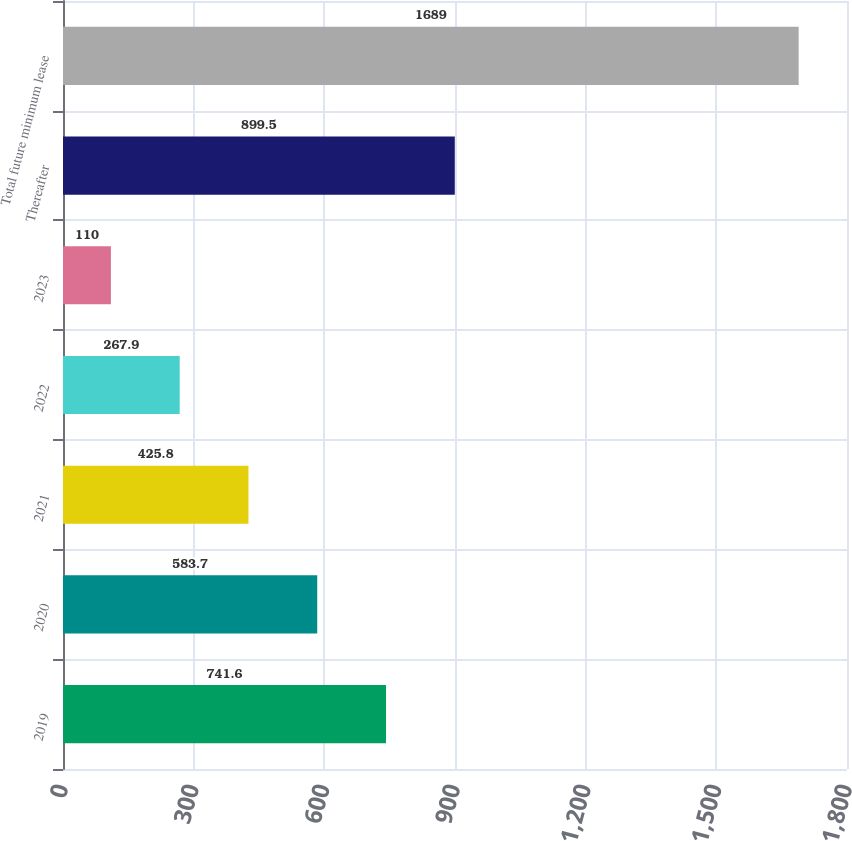<chart> <loc_0><loc_0><loc_500><loc_500><bar_chart><fcel>2019<fcel>2020<fcel>2021<fcel>2022<fcel>2023<fcel>Thereafter<fcel>Total future minimum lease<nl><fcel>741.6<fcel>583.7<fcel>425.8<fcel>267.9<fcel>110<fcel>899.5<fcel>1689<nl></chart> 